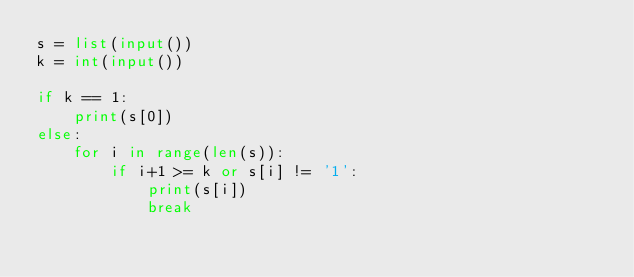Convert code to text. <code><loc_0><loc_0><loc_500><loc_500><_Python_>s = list(input())
k = int(input())

if k == 1:
    print(s[0])
else:
    for i in range(len(s)):
        if i+1 >= k or s[i] != '1':
            print(s[i])
            break</code> 